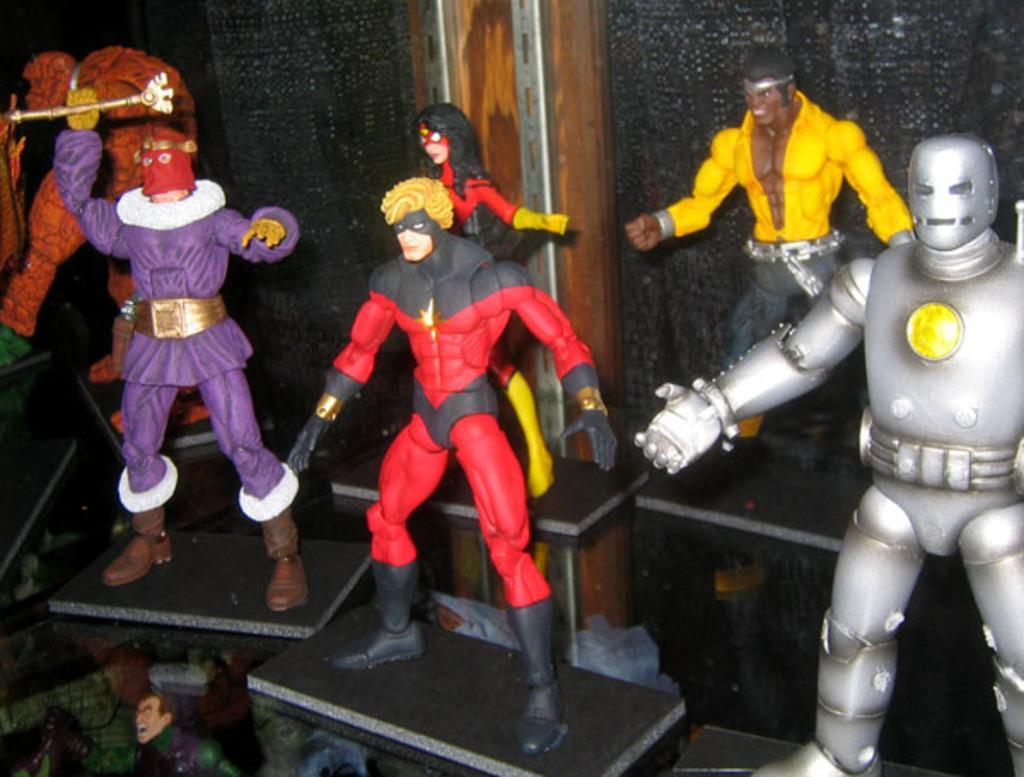How would you summarize this image in a sentence or two? In this image I can see toys. 